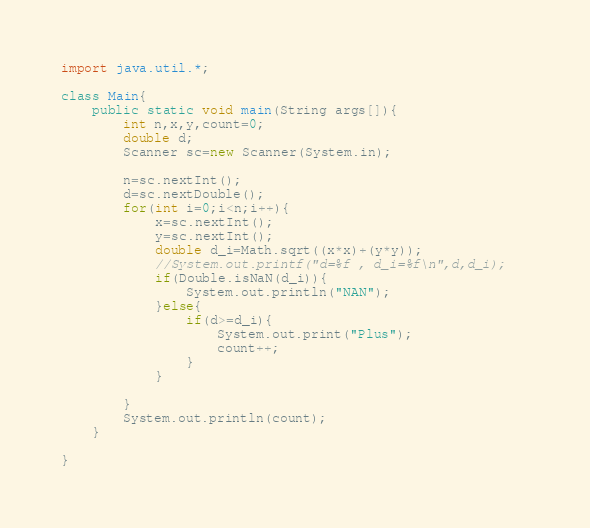<code> <loc_0><loc_0><loc_500><loc_500><_Java_>import java.util.*;

class Main{
    public static void main(String args[]){
        int n,x,y,count=0;
        double d;
        Scanner sc=new Scanner(System.in);

        n=sc.nextInt();
        d=sc.nextDouble();
        for(int i=0;i<n;i++){
            x=sc.nextInt();
            y=sc.nextInt();
            double d_i=Math.sqrt((x*x)+(y*y));
            //System.out.printf("d=%f , d_i=%f\n",d,d_i);   
            if(Double.isNaN(d_i)){
                System.out.println("NAN");
            }else{ 
                if(d>=d_i){
                    System.out.print("Plus");
                    count++;
                }
            }
            
        }
        System.out.println(count);
    }

}</code> 